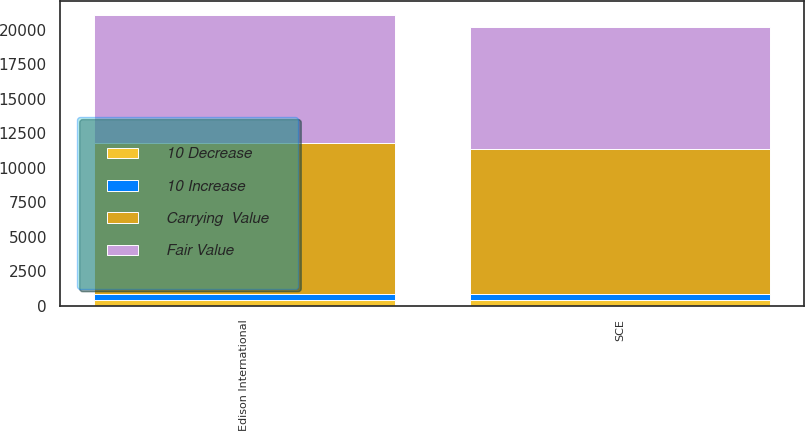Convert chart. <chart><loc_0><loc_0><loc_500><loc_500><stacked_bar_chart><ecel><fcel>SCE<fcel>Edison International<nl><fcel>Fair Value<fcel>8828<fcel>9231<nl><fcel>Carrying  Value<fcel>10505<fcel>10944<nl><fcel>10 Decrease<fcel>407<fcel>410<nl><fcel>10 Increase<fcel>438<fcel>441<nl></chart> 